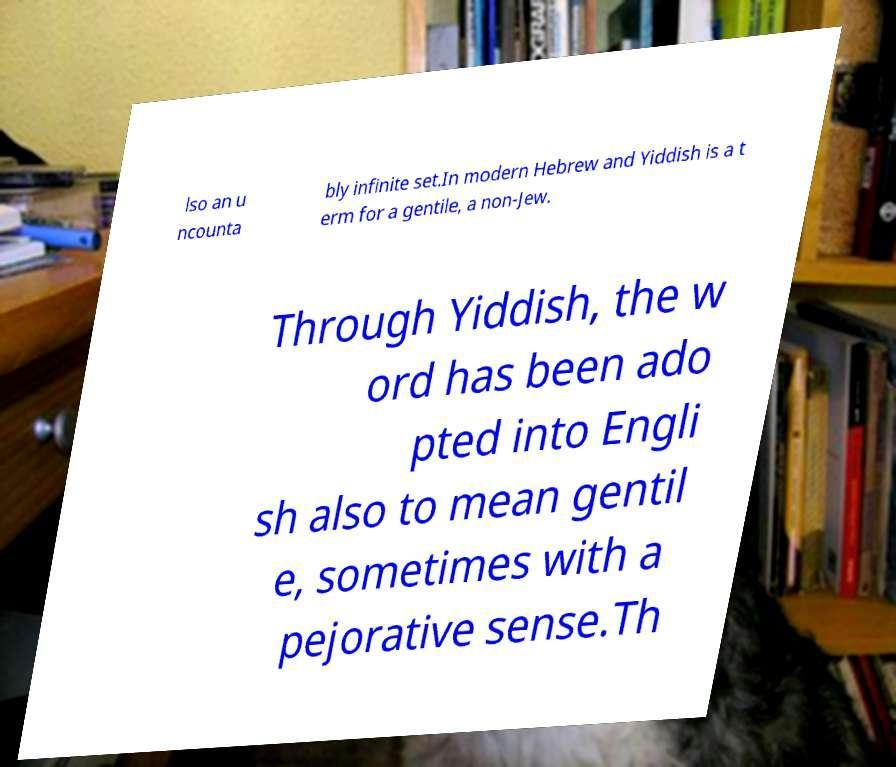Can you accurately transcribe the text from the provided image for me? lso an u ncounta bly infinite set.In modern Hebrew and Yiddish is a t erm for a gentile, a non-Jew. Through Yiddish, the w ord has been ado pted into Engli sh also to mean gentil e, sometimes with a pejorative sense.Th 